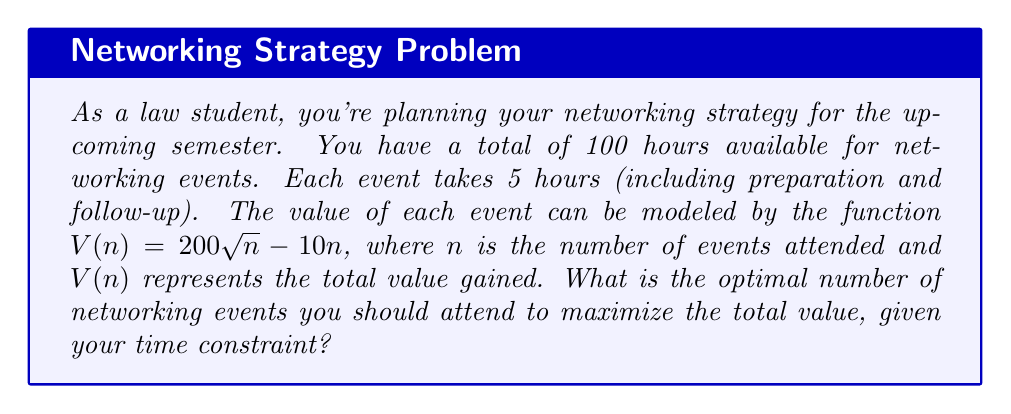Show me your answer to this math problem. Let's approach this step-by-step:

1) First, we need to consider the time constraint. With 100 hours available and each event taking 5 hours:
   Maximum number of events = $100 / 5 = 20$

2) Now, we need to find the maximum of the function $V(n) = 200\sqrt{n} - 10n$ within the range $0 \leq n \leq 20$.

3) To find the maximum, we differentiate $V(n)$ with respect to $n$:
   $$V'(n) = \frac{200}{2\sqrt{n}} - 10 = \frac{100}{\sqrt{n}} - 10$$

4) Set $V'(n) = 0$ to find the critical point:
   $$\frac{100}{\sqrt{n}} - 10 = 0$$
   $$\frac{100}{\sqrt{n}} = 10$$
   $$100 = 10\sqrt{n}$$
   $$10 = \sqrt{n}$$
   $$n = 100$$

5) However, $n = 100$ is outside our constraint of $n \leq 20$. This means the maximum within our constraint will occur at the boundary, which is $n = 20$.

6) To verify, we can check the value of $V'(n)$ at $n = 20$:
   $$V'(20) = \frac{100}{\sqrt{20}} - 10 \approx 12.36$$

   Since this is positive, it confirms that $V(n)$ is still increasing at $n = 20$.

7) Therefore, the optimal number of events to attend is 20, which is the maximum allowed by the time constraint.
Answer: 20 events 